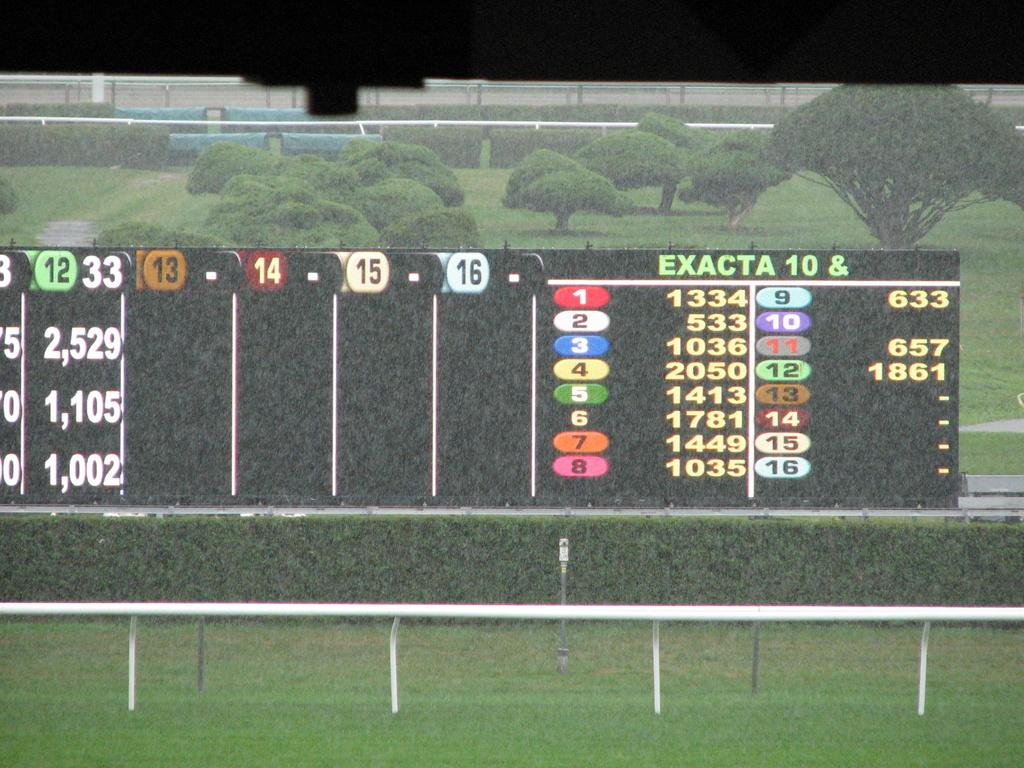Provide a one-sentence caption for the provided image. a scoreboard for a game with EXACTA 10 & with lists of numbers all over it. 